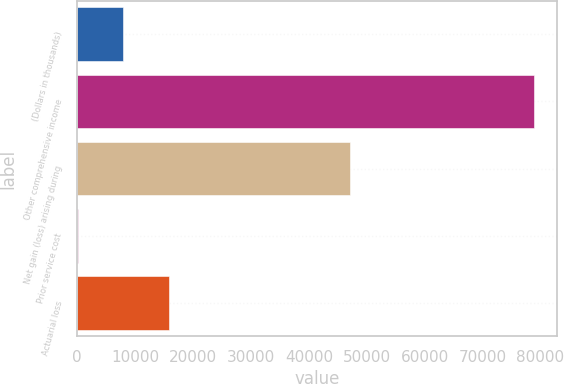Convert chart. <chart><loc_0><loc_0><loc_500><loc_500><bar_chart><fcel>(Dollars in thousands)<fcel>Other comprehensive income<fcel>Net gain (loss) arising during<fcel>Prior service cost<fcel>Actuarial loss<nl><fcel>7936.4<fcel>78923<fcel>47177<fcel>49<fcel>15823.8<nl></chart> 